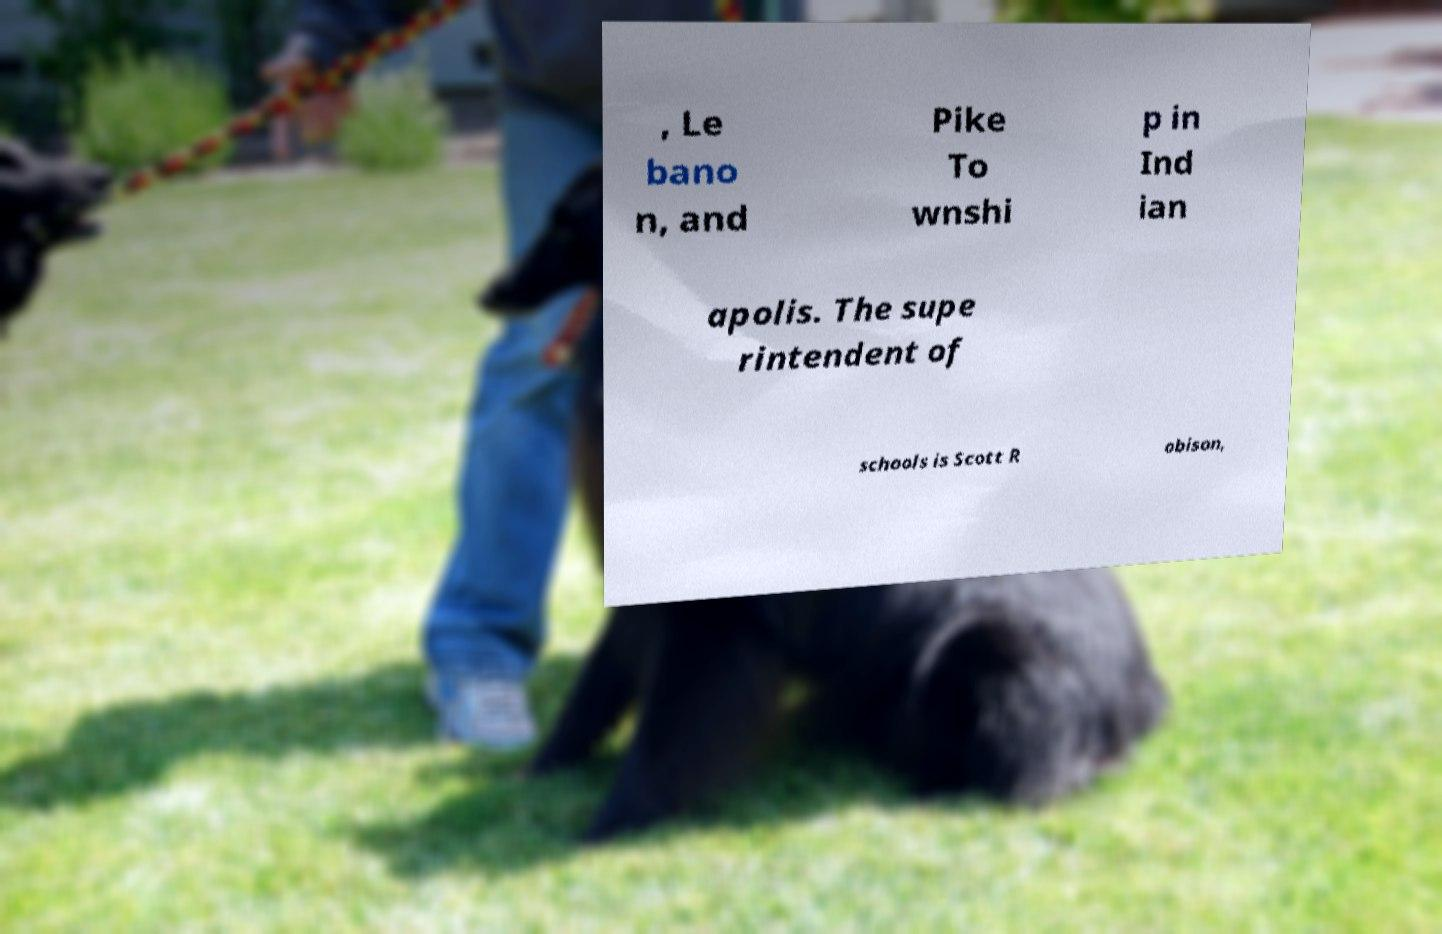There's text embedded in this image that I need extracted. Can you transcribe it verbatim? , Le bano n, and Pike To wnshi p in Ind ian apolis. The supe rintendent of schools is Scott R obison, 